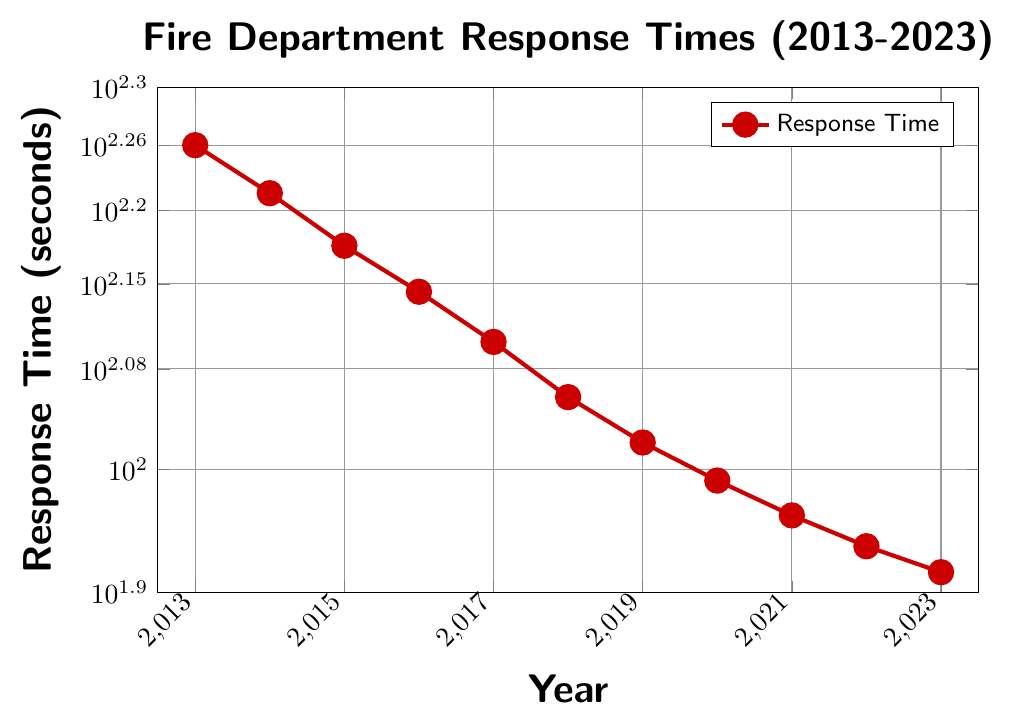What is the general trend of the response times from 2013 to 2023? The overall trend shows that the response times decrease over the years. By checking each year, we see a consistent reduction in the number of seconds taken for response.
Answer: Decreasing What is the average response time over the decade? To find the average, sum all the response times and divide by the number of years: (180 + 165 + 150 + 138 + 126 + 114 + 105 + 98 + 92 + 87 + 83) = 1338 seconds. Divide this by the number of years (11) to get the average: 1338 / 11 ≈ 121.64 seconds.
Answer: 121.64 seconds Which year had the fastest response time? By checking the response times, 2023 has the lowest response time at 83 seconds.
Answer: 2023 Which year saw the largest decrease in response time compared to the previous year? Calculate the yearly differences: 2014-2013: 15 seconds, 2015-2014: 15 seconds, 2016-2015: 12 seconds, 2017-2016: 12 seconds, 2018-2017: 12 seconds, 2019-2018: 9 seconds, 2020-2019: 7 seconds, 2021-2020: 6 seconds, 2022-2021: 5 seconds, 2023-2022: 4 seconds. Largest decrease is from 2014-2013 and 2015-2014 (both 15 seconds).
Answer: 2014 and 2015 How many years did it take for the response time to go below 100 seconds for the first time? Start from 2013, look through the years until the response time is below 100 seconds. In 2019, the response time is 98 seconds. That is 2019 - 2013 = 6 years.
Answer: 6 years Compare the response time in 2013 to the response time in 2023. By how much has it decreased? The response time in 2013 was 180 seconds, and in 2023 it is 83 seconds. The decrease is 180 - 83 = 97 seconds.
Answer: 97 seconds Describe the visual trend observed in the color of the plot markers over time. The markers remain consistently red for all years, but the height of the markers decreases over time, indicating shorter response times.
Answer: Consistent red, decreasing height What is the percentage decrease in response time from 2013 to 2023? Using the initial value (2013) and the final value (2023), the percentage decrease is calculated as ((180 - 83) / 180) * 100 = 53.89%.
Answer: 53.89% In which five-year span did the response times decrease the most? Calculate the difference for each five-year span:
2013-2018: 180 - 114 = 66 seconds,
2014-2019: 165 - 105 = 60 seconds,
2015-2020: 150 - 98 = 52 seconds,
2016-2021: 138 - 92 = 46 seconds,
2017-2022: 126 - 87 = 39 seconds,
2018-2023: 114 - 83 = 31 seconds.
Largest decrease is from 2013-2018 (66 seconds).
Answer: 2013-2018 